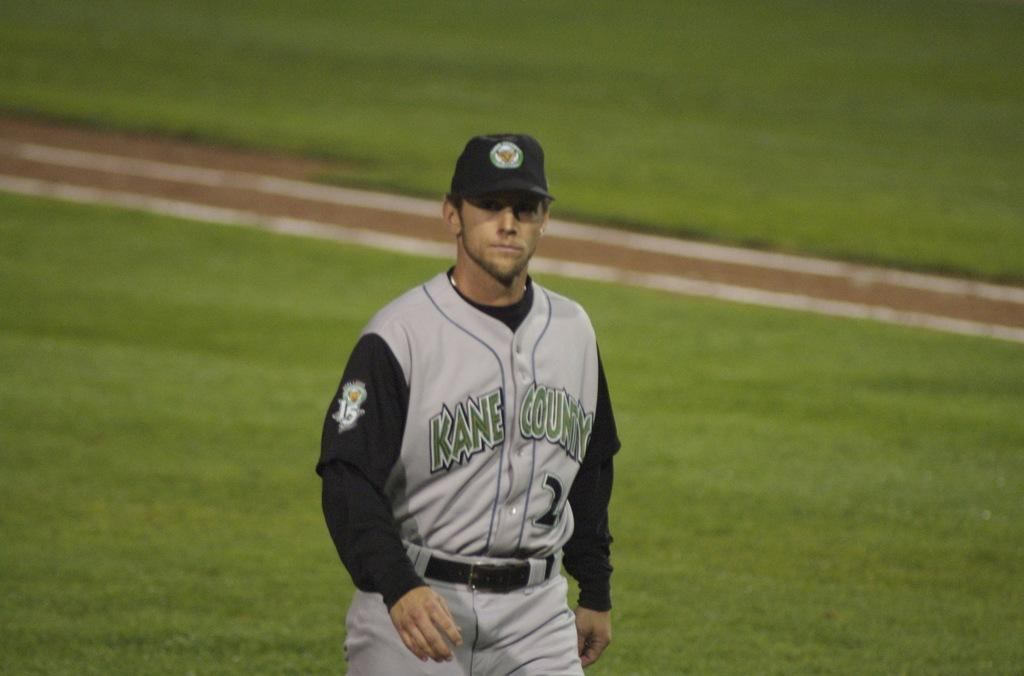<image>
Summarize the visual content of the image. A baseball player wearing a Kane Country uniform. 